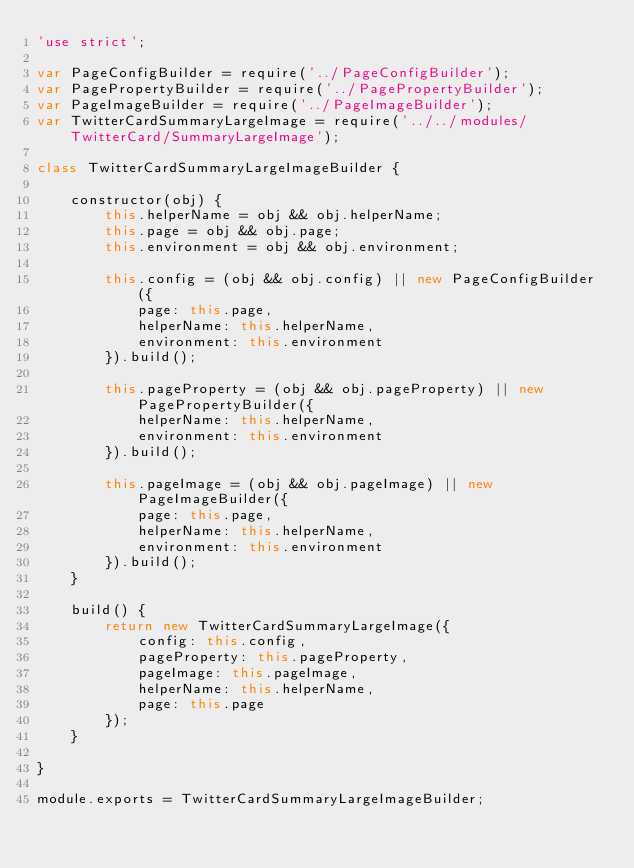<code> <loc_0><loc_0><loc_500><loc_500><_JavaScript_>'use strict';

var PageConfigBuilder = require('../PageConfigBuilder');
var PagePropertyBuilder = require('../PagePropertyBuilder');
var PageImageBuilder = require('../PageImageBuilder');
var TwitterCardSummaryLargeImage = require('../../modules/TwitterCard/SummaryLargeImage');

class TwitterCardSummaryLargeImageBuilder {

    constructor(obj) {
        this.helperName = obj && obj.helperName;
        this.page = obj && obj.page;
        this.environment = obj && obj.environment;

        this.config = (obj && obj.config) || new PageConfigBuilder({
            page: this.page,
            helperName: this.helperName,
            environment: this.environment
        }).build();

        this.pageProperty = (obj && obj.pageProperty) || new PagePropertyBuilder({
            helperName: this.helperName,
            environment: this.environment
        }).build();

        this.pageImage = (obj && obj.pageImage) || new PageImageBuilder({
            page: this.page,
            helperName: this.helperName,
            environment: this.environment
        }).build();
    }

    build() {
        return new TwitterCardSummaryLargeImage({
            config: this.config,
            pageProperty: this.pageProperty,
            pageImage: this.pageImage,
            helperName: this.helperName,
            page: this.page
        });
    }

}

module.exports = TwitterCardSummaryLargeImageBuilder;</code> 